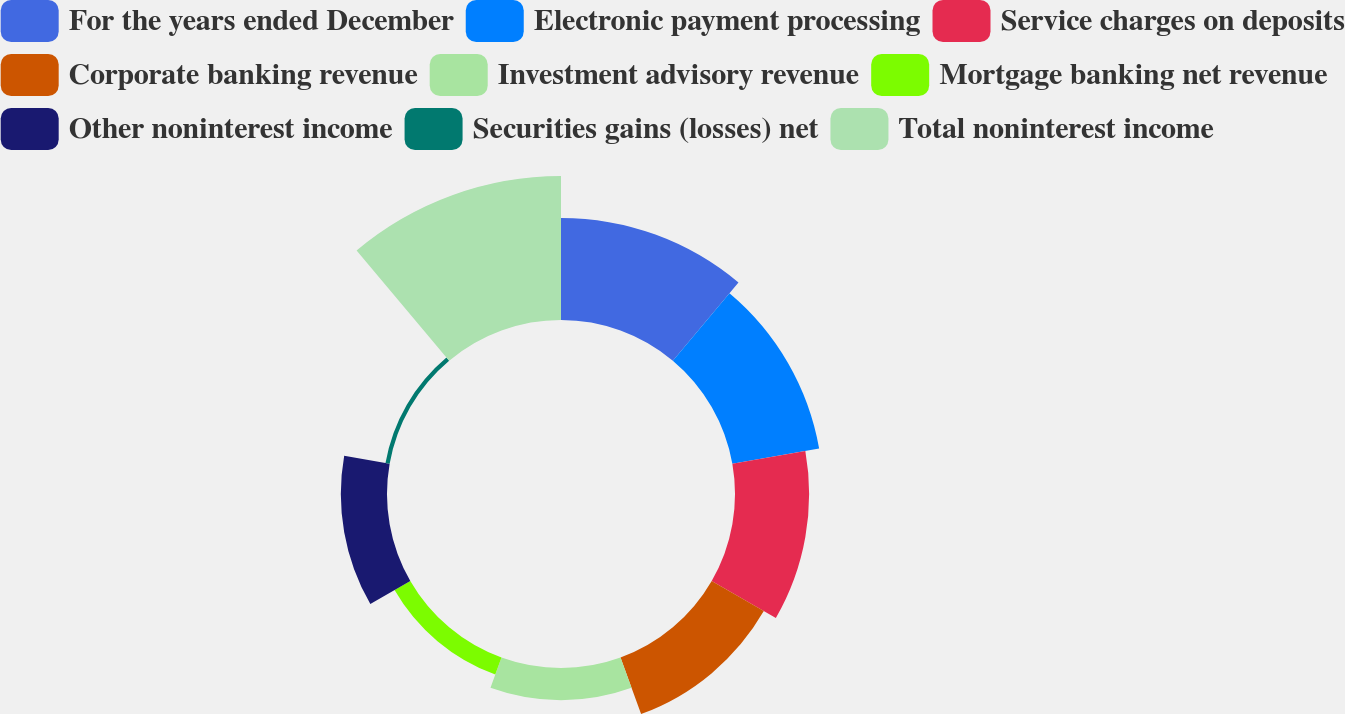Convert chart to OTSL. <chart><loc_0><loc_0><loc_500><loc_500><pie_chart><fcel>For the years ended December<fcel>Electronic payment processing<fcel>Service charges on deposits<fcel>Corporate banking revenue<fcel>Investment advisory revenue<fcel>Mortgage banking net revenue<fcel>Other noninterest income<fcel>Securities gains (losses) net<fcel>Total noninterest income<nl><fcel>17.94%<fcel>15.48%<fcel>13.02%<fcel>10.57%<fcel>5.65%<fcel>3.2%<fcel>8.11%<fcel>0.74%<fcel>25.3%<nl></chart> 